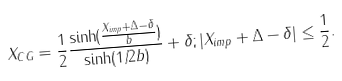<formula> <loc_0><loc_0><loc_500><loc_500>X _ { C G } = \frac { 1 } { 2 } \frac { \sinh ( \frac { X _ { i m p } + \Delta - \delta } { b } ) } { \sinh ( 1 / 2 b ) } + \delta ; | X _ { i m p } + \Delta - \delta | \leq \frac { 1 } { 2 } .</formula> 